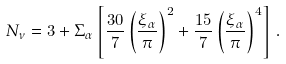Convert formula to latex. <formula><loc_0><loc_0><loc_500><loc_500>N _ { \nu } = 3 + \Sigma _ { \alpha } \left [ \frac { 3 0 } { 7 } \left ( \frac { \xi _ { \alpha } } { \pi } \right ) ^ { 2 } + \frac { 1 5 } { 7 } \left ( \frac { \xi _ { \alpha } } { \pi } \right ) ^ { 4 } \right ] \, .</formula> 